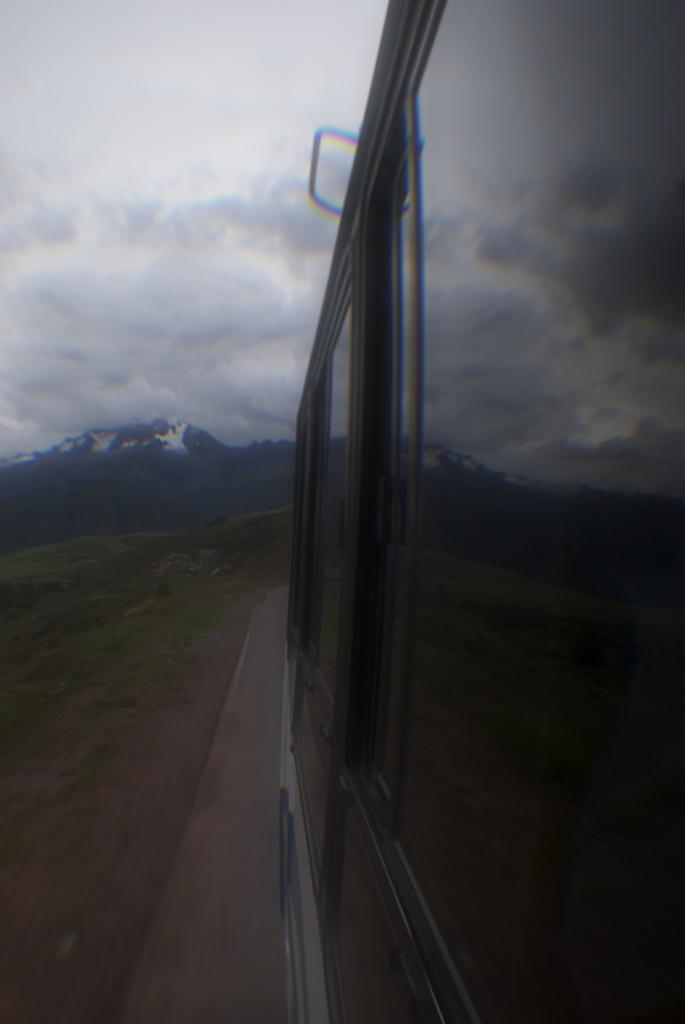What type of vehicle is depicted in the image? There are glasses of a vehicle in the image, but the specific type cannot be determined from the facts provided. What can be seen in the foreground of the image? There is a road visible in the image, as well as grass. What is visible in the background of the image? There is a mountain and the sky visible in the background of the image. What is the condition of the sky in the image? The sky is visible in the background of the image, and clouds are present. Can you tell me how many questions the kitty is asking in the image? There is no kitty present in the image, and therefore no questions can be attributed to it. Is there a camp visible in the image? There is no mention of a camp in the provided facts, and no such structure is visible in the image. 